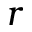Convert formula to latex. <formula><loc_0><loc_0><loc_500><loc_500>r</formula> 